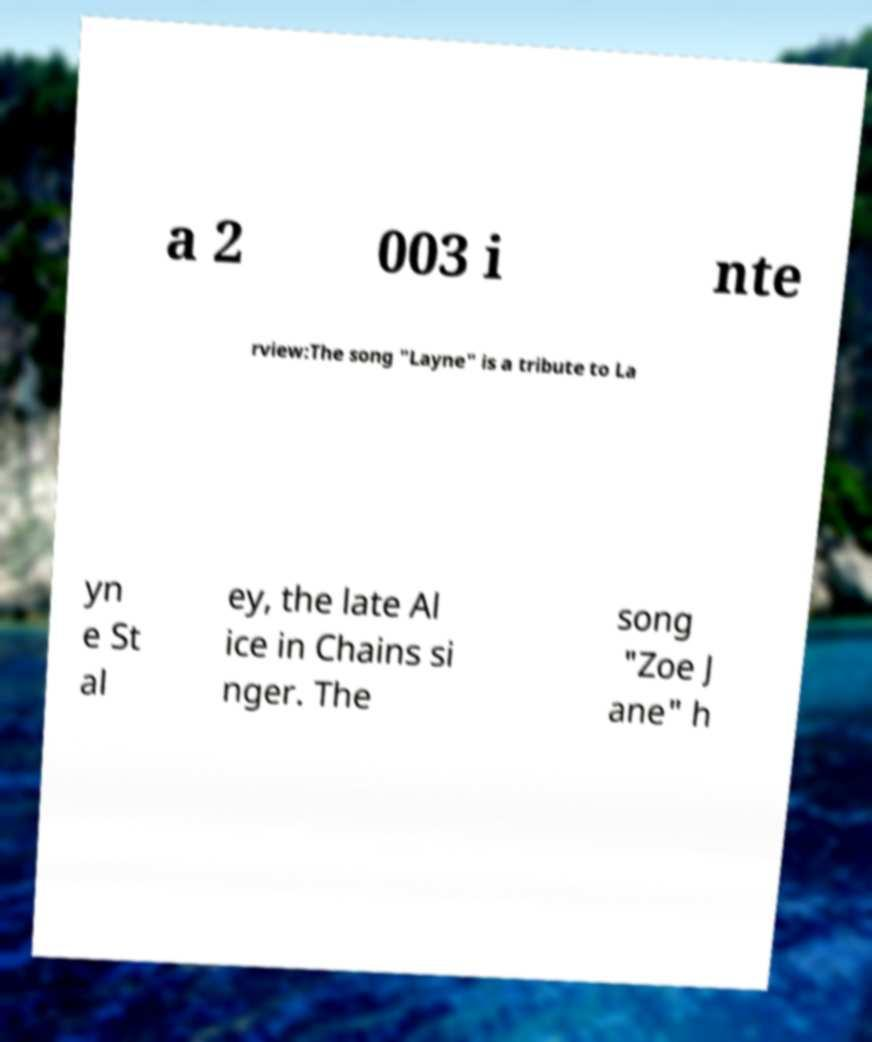Can you accurately transcribe the text from the provided image for me? a 2 003 i nte rview:The song "Layne" is a tribute to La yn e St al ey, the late Al ice in Chains si nger. The song "Zoe J ane" h 